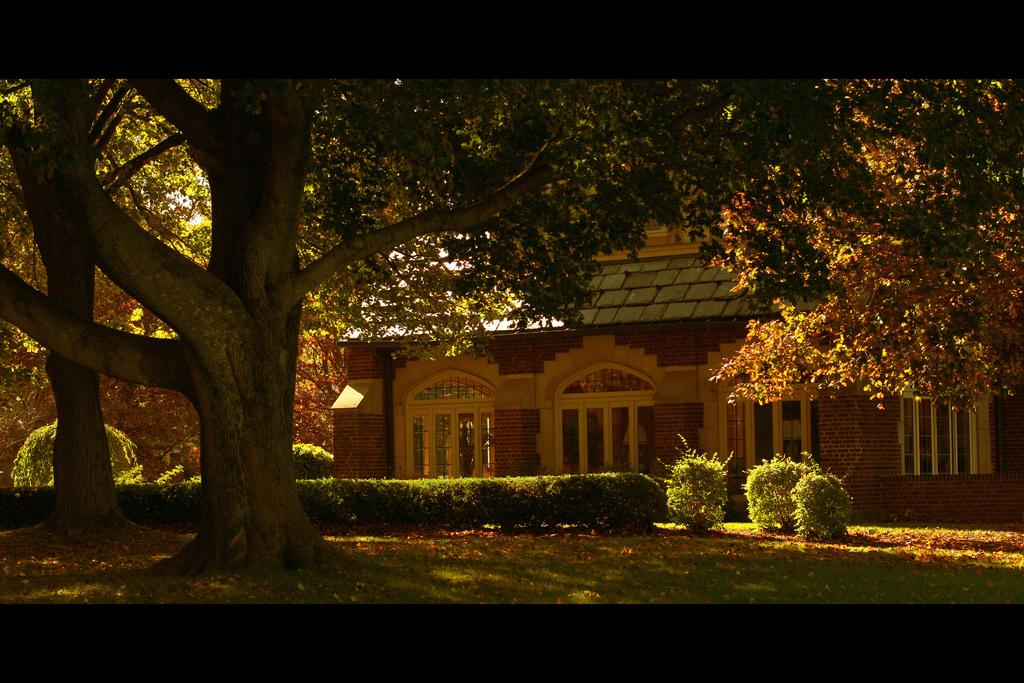What type of natural elements are present in the image? There are many trees and plants in the image. What type of structure can be seen in the background of the image? There is a house with windows in the background of the image. What part of the natural environment is visible in the image? The sky is visible in the image. How many nuts are scattered on the ground in the image? There are no nuts visible in the image; it primarily features trees and plants. What type of heat source can be seen in the image? There is no heat source present in the image. 